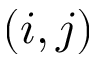Convert formula to latex. <formula><loc_0><loc_0><loc_500><loc_500>( i , j )</formula> 